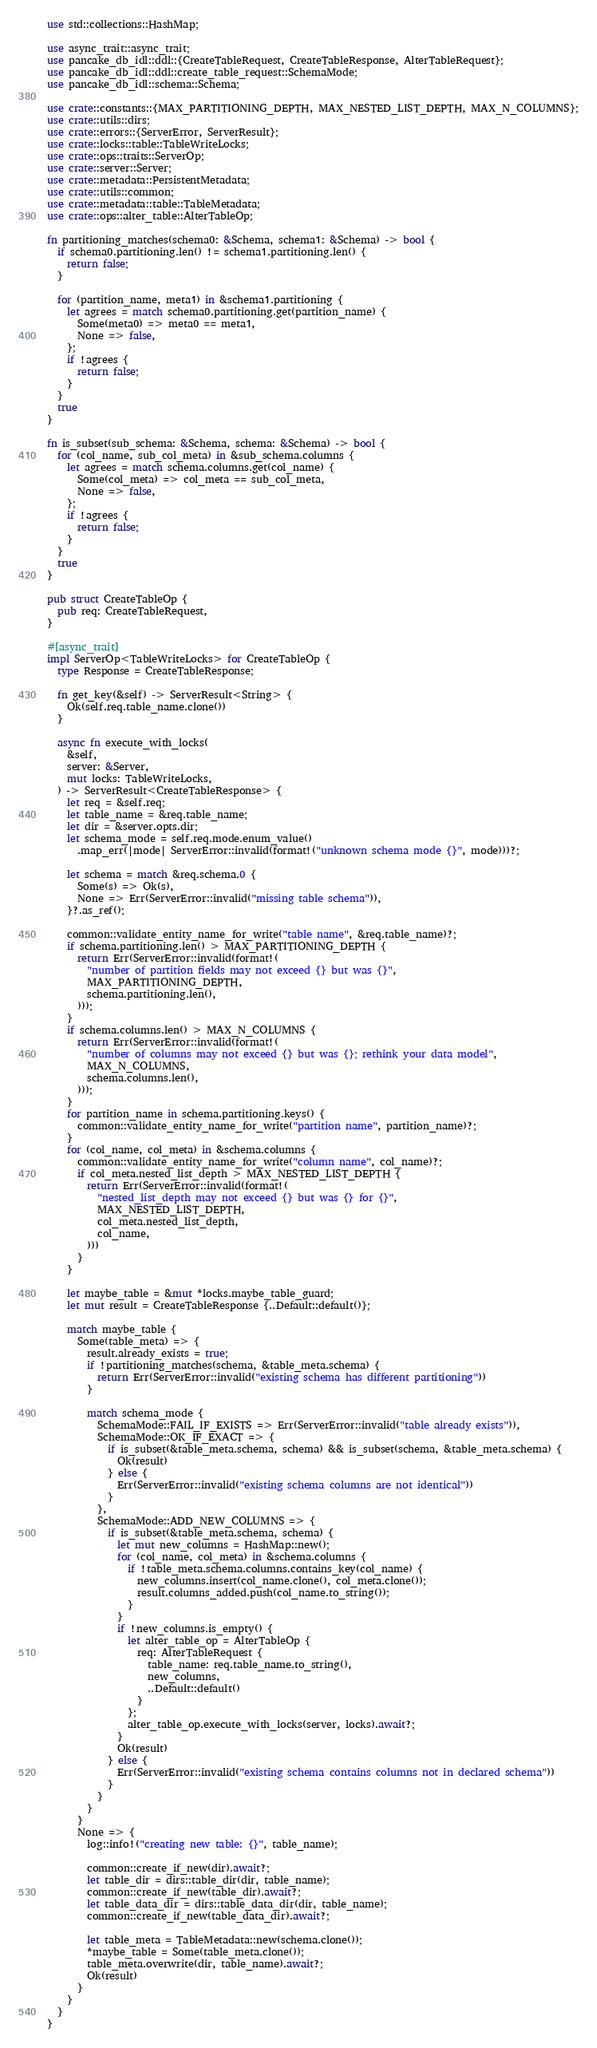Convert code to text. <code><loc_0><loc_0><loc_500><loc_500><_Rust_>use std::collections::HashMap;

use async_trait::async_trait;
use pancake_db_idl::ddl::{CreateTableRequest, CreateTableResponse, AlterTableRequest};
use pancake_db_idl::ddl::create_table_request::SchemaMode;
use pancake_db_idl::schema::Schema;

use crate::constants::{MAX_PARTITIONING_DEPTH, MAX_NESTED_LIST_DEPTH, MAX_N_COLUMNS};
use crate::utils::dirs;
use crate::errors::{ServerError, ServerResult};
use crate::locks::table::TableWriteLocks;
use crate::ops::traits::ServerOp;
use crate::server::Server;
use crate::metadata::PersistentMetadata;
use crate::utils::common;
use crate::metadata::table::TableMetadata;
use crate::ops::alter_table::AlterTableOp;

fn partitioning_matches(schema0: &Schema, schema1: &Schema) -> bool {
  if schema0.partitioning.len() != schema1.partitioning.len() {
    return false;
  }

  for (partition_name, meta1) in &schema1.partitioning {
    let agrees = match schema0.partitioning.get(partition_name) {
      Some(meta0) => meta0 == meta1,
      None => false,
    };
    if !agrees {
      return false;
    }
  }
  true
}

fn is_subset(sub_schema: &Schema, schema: &Schema) -> bool {
  for (col_name, sub_col_meta) in &sub_schema.columns {
    let agrees = match schema.columns.get(col_name) {
      Some(col_meta) => col_meta == sub_col_meta,
      None => false,
    };
    if !agrees {
      return false;
    }
  }
  true
}

pub struct CreateTableOp {
  pub req: CreateTableRequest,
}

#[async_trait]
impl ServerOp<TableWriteLocks> for CreateTableOp {
  type Response = CreateTableResponse;

  fn get_key(&self) -> ServerResult<String> {
    Ok(self.req.table_name.clone())
  }

  async fn execute_with_locks(
    &self,
    server: &Server,
    mut locks: TableWriteLocks,
  ) -> ServerResult<CreateTableResponse> {
    let req = &self.req;
    let table_name = &req.table_name;
    let dir = &server.opts.dir;
    let schema_mode = self.req.mode.enum_value()
      .map_err(|mode| ServerError::invalid(format!("unknown schema mode {}", mode)))?;

    let schema = match &req.schema.0 {
      Some(s) => Ok(s),
      None => Err(ServerError::invalid("missing table schema")),
    }?.as_ref();

    common::validate_entity_name_for_write("table name", &req.table_name)?;
    if schema.partitioning.len() > MAX_PARTITIONING_DEPTH {
      return Err(ServerError::invalid(format!(
        "number of partition fields may not exceed {} but was {}",
        MAX_PARTITIONING_DEPTH,
        schema.partitioning.len(),
      )));
    }
    if schema.columns.len() > MAX_N_COLUMNS {
      return Err(ServerError::invalid(format!(
        "number of columns may not exceed {} but was {}; rethink your data model",
        MAX_N_COLUMNS,
        schema.columns.len(),
      )));
    }
    for partition_name in schema.partitioning.keys() {
      common::validate_entity_name_for_write("partition name", partition_name)?;
    }
    for (col_name, col_meta) in &schema.columns {
      common::validate_entity_name_for_write("column name", col_name)?;
      if col_meta.nested_list_depth > MAX_NESTED_LIST_DEPTH {
        return Err(ServerError::invalid(format!(
          "nested_list_depth may not exceed {} but was {} for {}",
          MAX_NESTED_LIST_DEPTH,
          col_meta.nested_list_depth,
          col_name,
        )))
      }
    }

    let maybe_table = &mut *locks.maybe_table_guard;
    let mut result = CreateTableResponse {..Default::default()};

    match maybe_table {
      Some(table_meta) => {
        result.already_exists = true;
        if !partitioning_matches(schema, &table_meta.schema) {
          return Err(ServerError::invalid("existing schema has different partitioning"))
        }

        match schema_mode {
          SchemaMode::FAIL_IF_EXISTS => Err(ServerError::invalid("table already exists")),
          SchemaMode::OK_IF_EXACT => {
            if is_subset(&table_meta.schema, schema) && is_subset(schema, &table_meta.schema) {
              Ok(result)
            } else {
              Err(ServerError::invalid("existing schema columns are not identical"))
            }
          },
          SchemaMode::ADD_NEW_COLUMNS => {
            if is_subset(&table_meta.schema, schema) {
              let mut new_columns = HashMap::new();
              for (col_name, col_meta) in &schema.columns {
                if !table_meta.schema.columns.contains_key(col_name) {
                  new_columns.insert(col_name.clone(), col_meta.clone());
                  result.columns_added.push(col_name.to_string());
                }
              }
              if !new_columns.is_empty() {
                let alter_table_op = AlterTableOp {
                  req: AlterTableRequest {
                    table_name: req.table_name.to_string(),
                    new_columns,
                    ..Default::default()
                  }
                };
                alter_table_op.execute_with_locks(server, locks).await?;
              }
              Ok(result)
            } else {
              Err(ServerError::invalid("existing schema contains columns not in declared schema"))
            }
          }
        }
      }
      None => {
        log::info!("creating new table: {}", table_name);

        common::create_if_new(dir).await?;
        let table_dir = dirs::table_dir(dir, table_name);
        common::create_if_new(table_dir).await?;
        let table_data_dir = dirs::table_data_dir(dir, table_name);
        common::create_if_new(table_data_dir).await?;

        let table_meta = TableMetadata::new(schema.clone());
        *maybe_table = Some(table_meta.clone());
        table_meta.overwrite(dir, table_name).await?;
        Ok(result)
      }
    }
  }
}</code> 